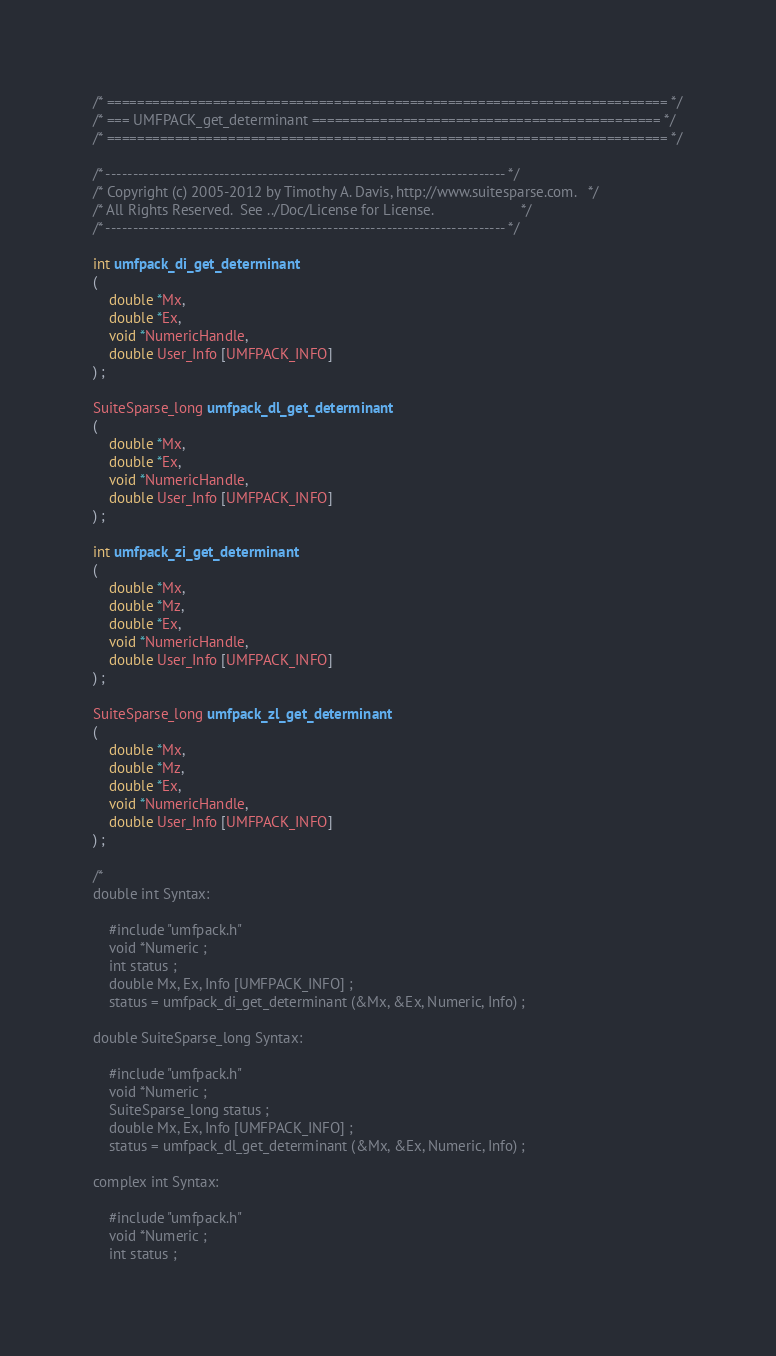Convert code to text. <code><loc_0><loc_0><loc_500><loc_500><_C_>/* ========================================================================== */
/* === UMFPACK_get_determinant ============================================== */
/* ========================================================================== */

/* -------------------------------------------------------------------------- */
/* Copyright (c) 2005-2012 by Timothy A. Davis, http://www.suitesparse.com.   */
/* All Rights Reserved.  See ../Doc/License for License.                      */
/* -------------------------------------------------------------------------- */

int umfpack_di_get_determinant
(
    double *Mx,
    double *Ex,
    void *NumericHandle,
    double User_Info [UMFPACK_INFO]
) ;

SuiteSparse_long umfpack_dl_get_determinant
(
    double *Mx,
    double *Ex,
    void *NumericHandle,
    double User_Info [UMFPACK_INFO]
) ;

int umfpack_zi_get_determinant
(
    double *Mx,
    double *Mz,
    double *Ex,
    void *NumericHandle,
    double User_Info [UMFPACK_INFO]
) ;

SuiteSparse_long umfpack_zl_get_determinant
(
    double *Mx,
    double *Mz,
    double *Ex,
    void *NumericHandle,
    double User_Info [UMFPACK_INFO]
) ;

/*
double int Syntax:

    #include "umfpack.h"
    void *Numeric ;
    int status ;
    double Mx, Ex, Info [UMFPACK_INFO] ;
    status = umfpack_di_get_determinant (&Mx, &Ex, Numeric, Info) ;

double SuiteSparse_long Syntax:

    #include "umfpack.h"
    void *Numeric ;
    SuiteSparse_long status ;
    double Mx, Ex, Info [UMFPACK_INFO] ;
    status = umfpack_dl_get_determinant (&Mx, &Ex, Numeric, Info) ;

complex int Syntax:

    #include "umfpack.h"
    void *Numeric ;
    int status ;</code> 